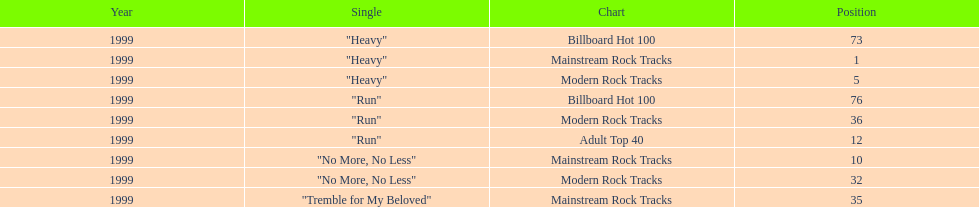How many singles from "dosage" featured on the modern rock tracks charts? 3. 